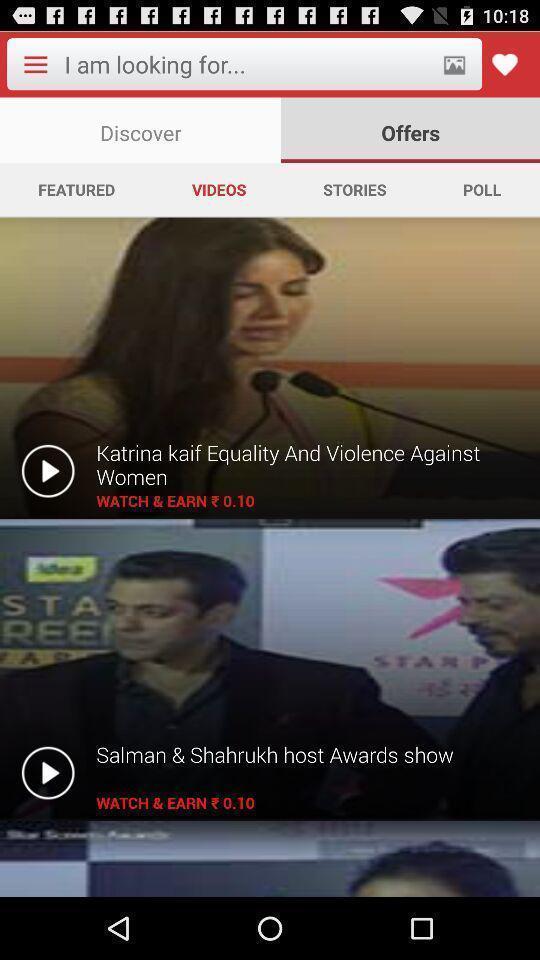Describe this image in words. Page showing different videos. 